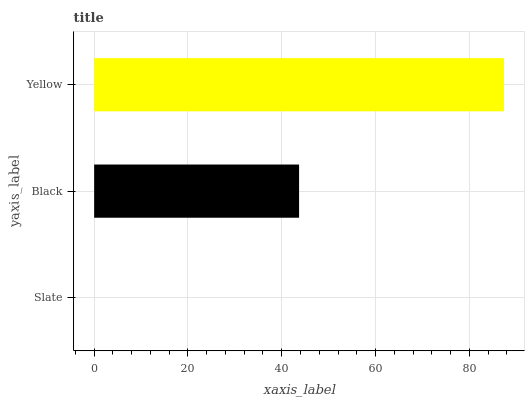Is Slate the minimum?
Answer yes or no. Yes. Is Yellow the maximum?
Answer yes or no. Yes. Is Black the minimum?
Answer yes or no. No. Is Black the maximum?
Answer yes or no. No. Is Black greater than Slate?
Answer yes or no. Yes. Is Slate less than Black?
Answer yes or no. Yes. Is Slate greater than Black?
Answer yes or no. No. Is Black less than Slate?
Answer yes or no. No. Is Black the high median?
Answer yes or no. Yes. Is Black the low median?
Answer yes or no. Yes. Is Yellow the high median?
Answer yes or no. No. Is Yellow the low median?
Answer yes or no. No. 